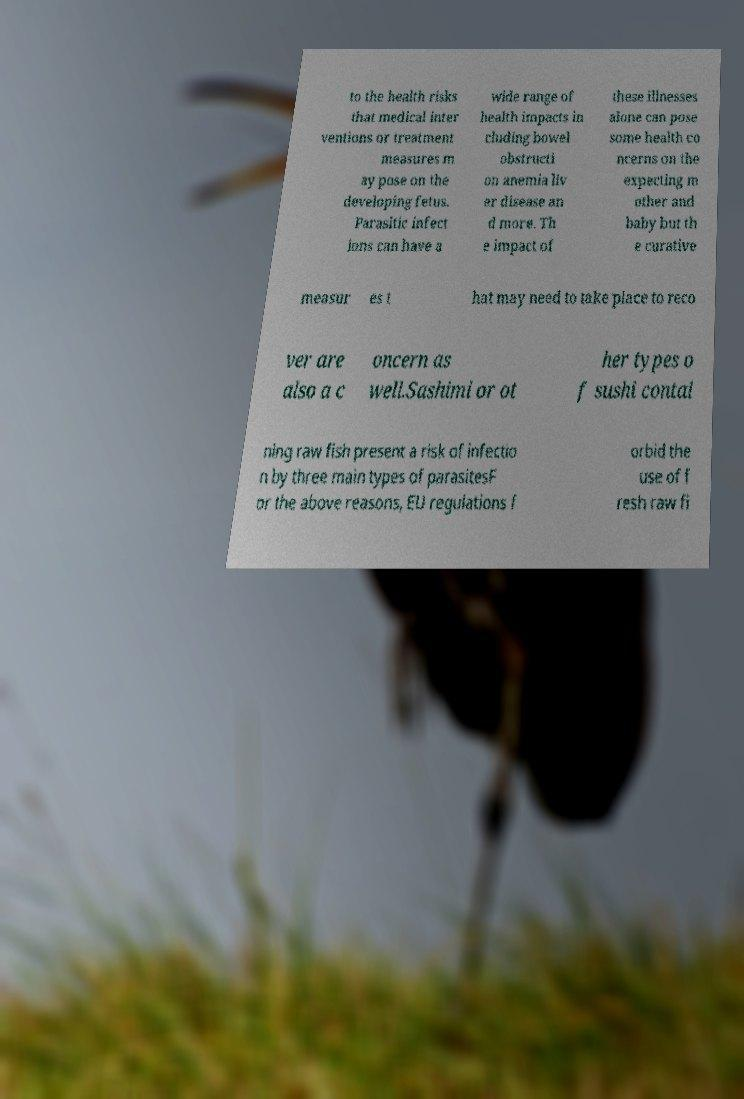Please read and relay the text visible in this image. What does it say? to the health risks that medical inter ventions or treatment measures m ay pose on the developing fetus. Parasitic infect ions can have a wide range of health impacts in cluding bowel obstructi on anemia liv er disease an d more. Th e impact of these illnesses alone can pose some health co ncerns on the expecting m other and baby but th e curative measur es t hat may need to take place to reco ver are also a c oncern as well.Sashimi or ot her types o f sushi contai ning raw fish present a risk of infectio n by three main types of parasitesF or the above reasons, EU regulations f orbid the use of f resh raw fi 